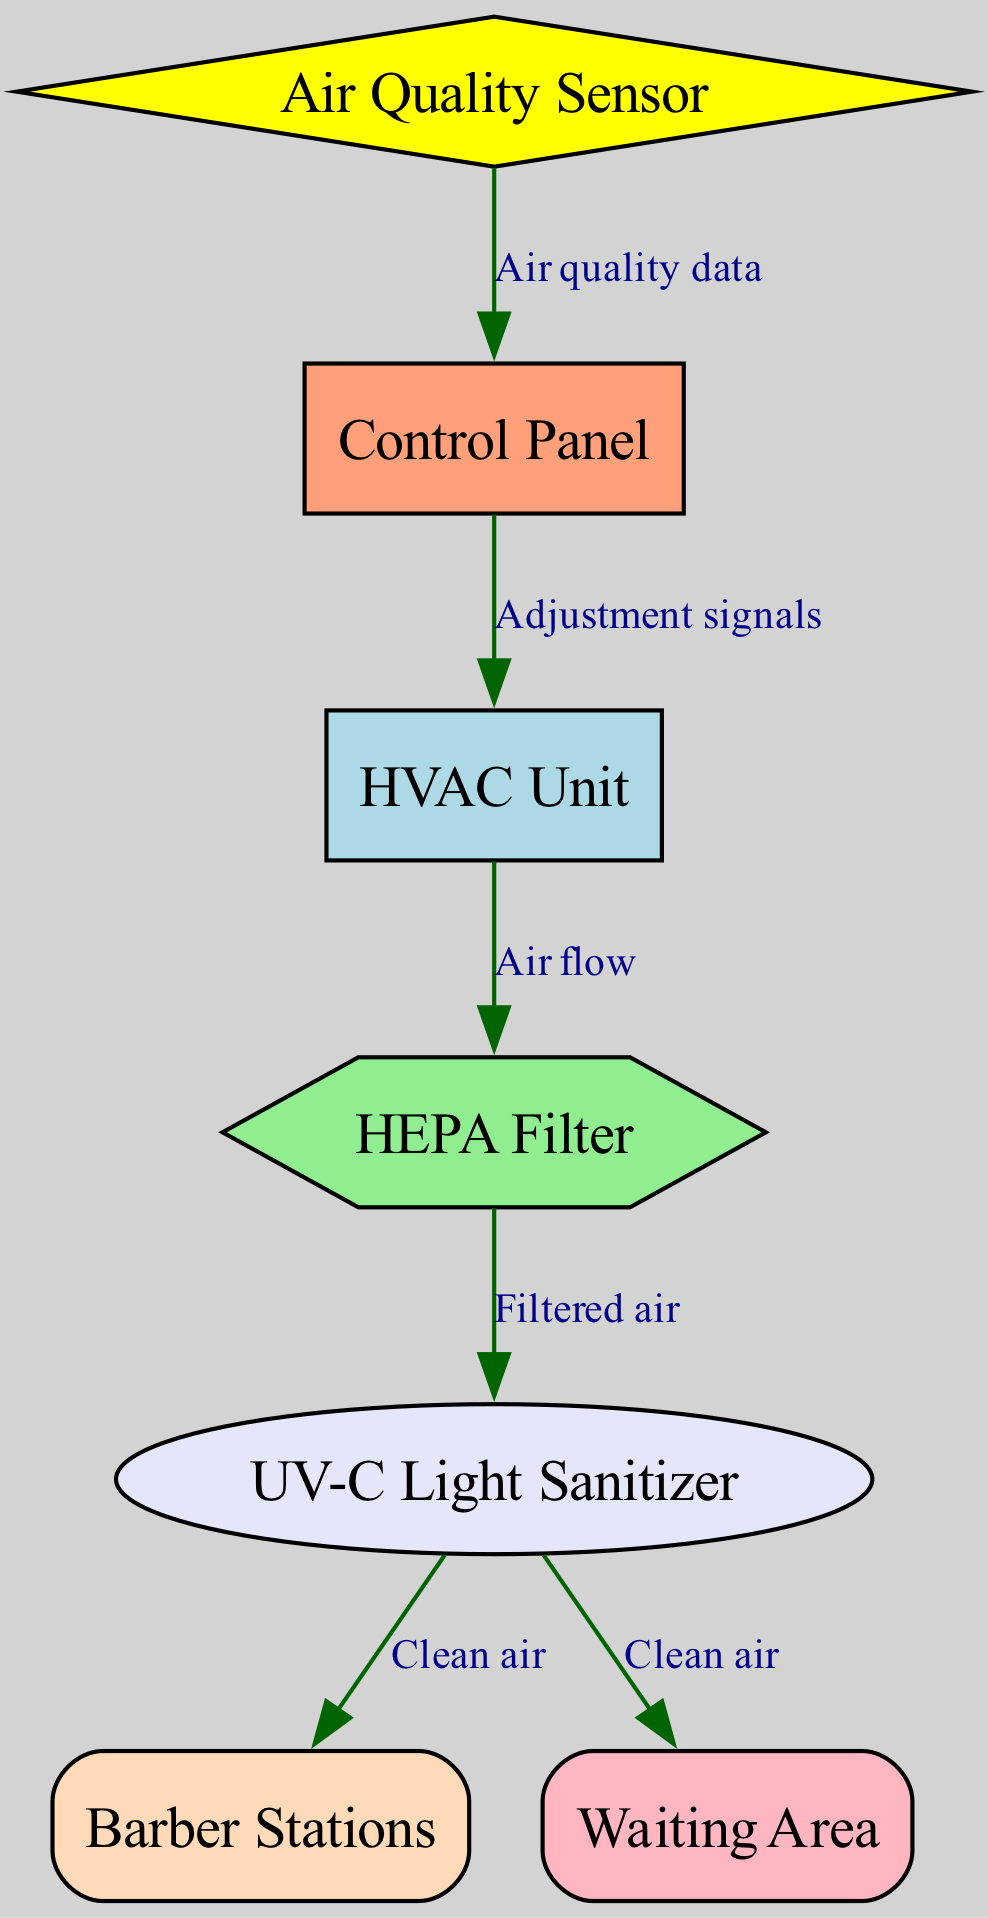What are the main components of the ventilation system? The diagram lists the nodes, which are the main components: HVAC Unit, Air Quality Sensor, HEPA Filter, UV-C Light Sanitizer, Barber Stations, Waiting Area, and Control Panel.
Answer: HVAC Unit, Air Quality Sensor, HEPA Filter, UV-C Light Sanitizer, Barber Stations, Waiting Area, Control Panel How many nodes are there in the diagram? Counting the nodes present in the diagram, we identify a total of seven nodes.
Answer: 7 What type of relationship exists between the HVAC Unit and the HEPA Filter? The edge indicating the relationship shows that air flows from the HVAC Unit to the HEPA Filter, establishing a directional relationship.
Answer: Air flow Where does the clean air from the UV-C Light Sanitizer go? The diagram displays two edges leading from the UV-C Light Sanitizer to both Barber Stations and Waiting Area, showing the destinations of the clean air.
Answer: Barber Stations, Waiting Area What data does the Air Quality Sensor send to the Control Panel? The edge labeled "Air quality data" indicates that the Air Quality Sensor provides data to the Control Panel, showing a specific type of information transmitted.
Answer: Air quality data Which component receives adjustment signals from the Control Panel? According to the diagram, the Control Panel sends adjustment signals to the HVAC Unit, indicating which component is influenced.
Answer: HVAC Unit What is the function of the UV-C Light Sanitizer in the system? The edges show that the UV-C Light Sanitizer provides clean air to both Barber Stations and Waiting Area, implying that its function is to sanitize the air.
Answer: Sanitize air How does the air quality affect the HVAC Unit? The Air Quality Sensor monitors air quality and sends corresponding adjustment signals to the HVAC Unit to optimize air flow and quality.
Answer: Adjustment signals 